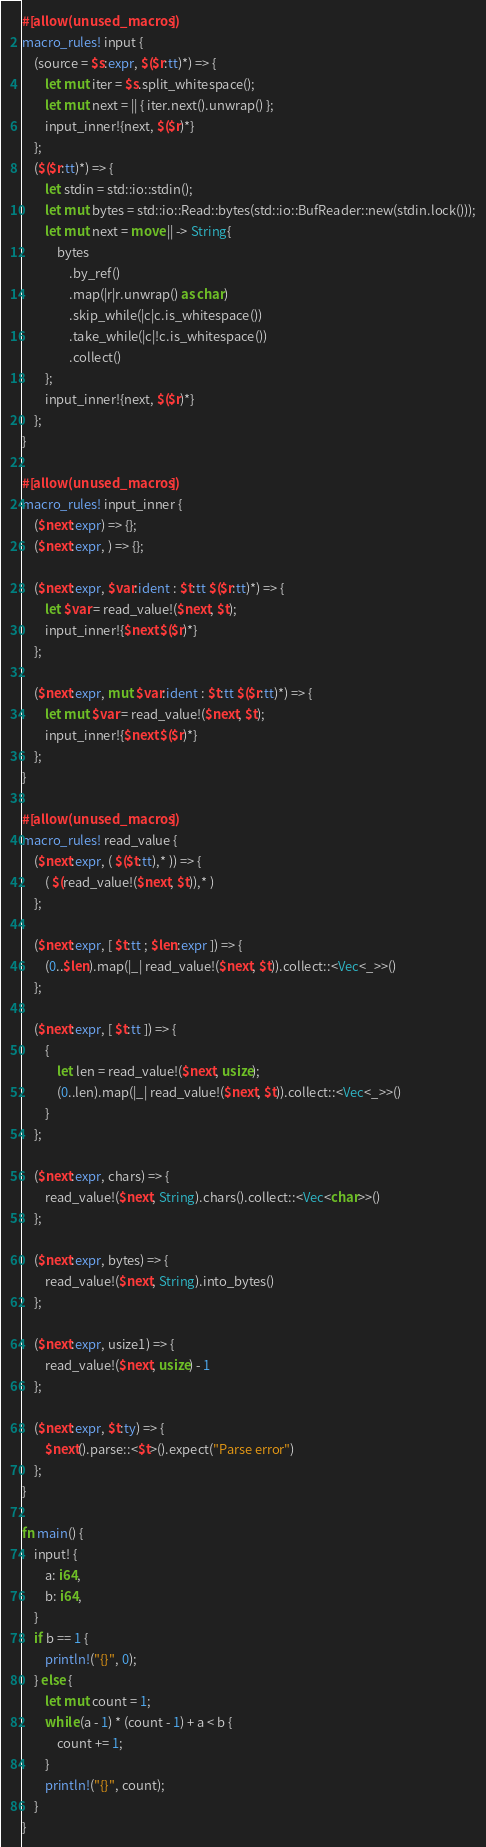<code> <loc_0><loc_0><loc_500><loc_500><_Rust_>#[allow(unused_macros)]
macro_rules! input {
    (source = $s:expr, $($r:tt)*) => {
        let mut iter = $s.split_whitespace();
        let mut next = || { iter.next().unwrap() };
        input_inner!{next, $($r)*}
    };
    ($($r:tt)*) => {
        let stdin = std::io::stdin();
        let mut bytes = std::io::Read::bytes(std::io::BufReader::new(stdin.lock()));
        let mut next = move || -> String{
            bytes
                .by_ref()
                .map(|r|r.unwrap() as char)
                .skip_while(|c|c.is_whitespace())
                .take_while(|c|!c.is_whitespace())
                .collect()
        };
        input_inner!{next, $($r)*}
    };
}

#[allow(unused_macros)]
macro_rules! input_inner {
    ($next:expr) => {};
    ($next:expr, ) => {};

    ($next:expr, $var:ident : $t:tt $($r:tt)*) => {
        let $var = read_value!($next, $t);
        input_inner!{$next $($r)*}
    };

    ($next:expr, mut $var:ident : $t:tt $($r:tt)*) => {
        let mut $var = read_value!($next, $t);
        input_inner!{$next $($r)*}
    };
}

#[allow(unused_macros)]
macro_rules! read_value {
    ($next:expr, ( $($t:tt),* )) => {
        ( $(read_value!($next, $t)),* )
    };

    ($next:expr, [ $t:tt ; $len:expr ]) => {
        (0..$len).map(|_| read_value!($next, $t)).collect::<Vec<_>>()
    };

    ($next:expr, [ $t:tt ]) => {
        {
            let len = read_value!($next, usize);
            (0..len).map(|_| read_value!($next, $t)).collect::<Vec<_>>()
        }
    };

    ($next:expr, chars) => {
        read_value!($next, String).chars().collect::<Vec<char>>()
    };

    ($next:expr, bytes) => {
        read_value!($next, String).into_bytes()
    };

    ($next:expr, usize1) => {
        read_value!($next, usize) - 1
    };

    ($next:expr, $t:ty) => {
        $next().parse::<$t>().expect("Parse error")
    };
}

fn main() {
    input! {
        a: i64,
        b: i64,
    }
    if b == 1 {
        println!("{}", 0);
    } else {
        let mut count = 1;
        while (a - 1) * (count - 1) + a < b {
            count += 1;
        }
        println!("{}", count);
    }
}
</code> 